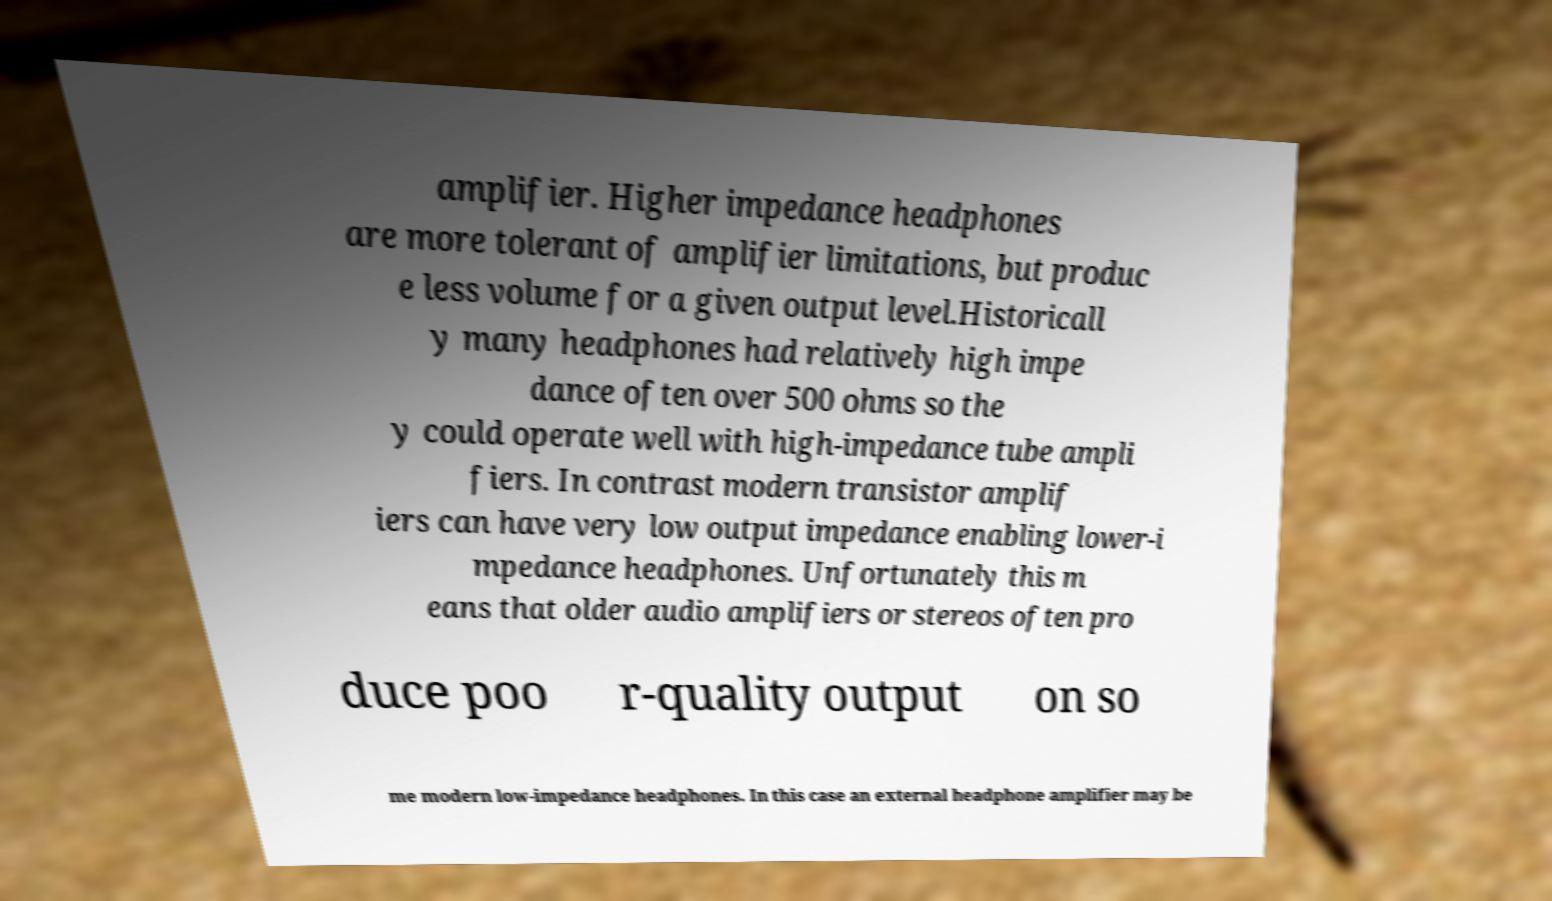Could you assist in decoding the text presented in this image and type it out clearly? amplifier. Higher impedance headphones are more tolerant of amplifier limitations, but produc e less volume for a given output level.Historicall y many headphones had relatively high impe dance often over 500 ohms so the y could operate well with high-impedance tube ampli fiers. In contrast modern transistor amplif iers can have very low output impedance enabling lower-i mpedance headphones. Unfortunately this m eans that older audio amplifiers or stereos often pro duce poo r-quality output on so me modern low-impedance headphones. In this case an external headphone amplifier may be 